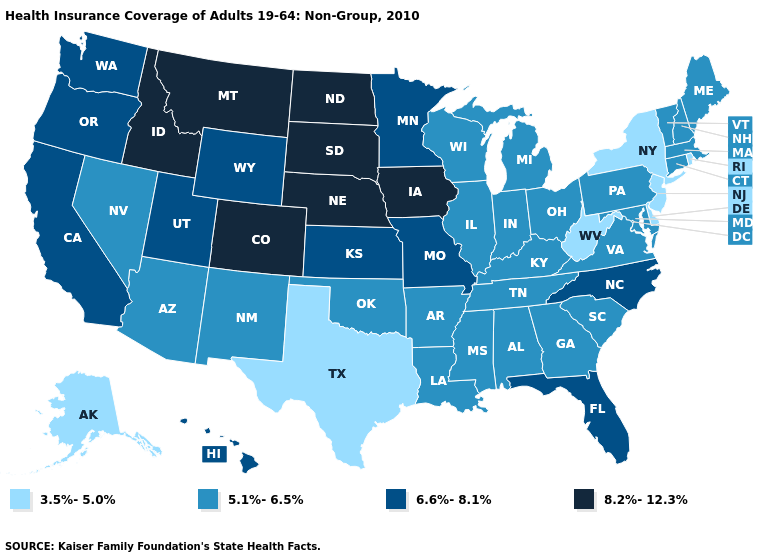Does Colorado have the highest value in the USA?
Keep it brief. Yes. Name the states that have a value in the range 3.5%-5.0%?
Be succinct. Alaska, Delaware, New Jersey, New York, Rhode Island, Texas, West Virginia. What is the highest value in states that border Montana?
Concise answer only. 8.2%-12.3%. Among the states that border Ohio , which have the lowest value?
Concise answer only. West Virginia. What is the value of Virginia?
Keep it brief. 5.1%-6.5%. What is the lowest value in states that border Michigan?
Concise answer only. 5.1%-6.5%. Does Pennsylvania have the same value as Georgia?
Give a very brief answer. Yes. What is the value of Nebraska?
Answer briefly. 8.2%-12.3%. Which states hav the highest value in the Northeast?
Keep it brief. Connecticut, Maine, Massachusetts, New Hampshire, Pennsylvania, Vermont. Does Oregon have the same value as Wyoming?
Concise answer only. Yes. What is the highest value in the MidWest ?
Short answer required. 8.2%-12.3%. Name the states that have a value in the range 3.5%-5.0%?
Short answer required. Alaska, Delaware, New Jersey, New York, Rhode Island, Texas, West Virginia. Does Mississippi have the highest value in the South?
Be succinct. No. Which states hav the highest value in the South?
Quick response, please. Florida, North Carolina. 